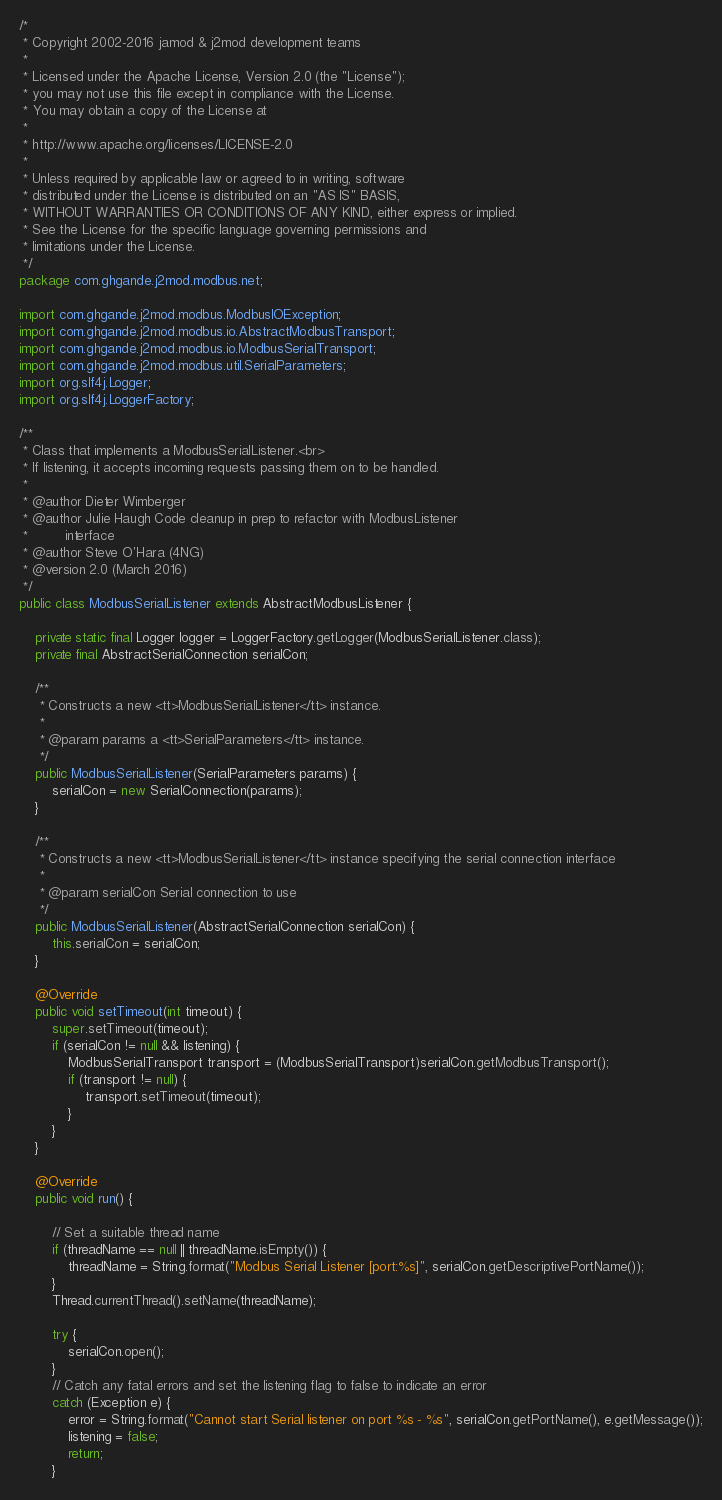<code> <loc_0><loc_0><loc_500><loc_500><_Java_>/*
 * Copyright 2002-2016 jamod & j2mod development teams
 *
 * Licensed under the Apache License, Version 2.0 (the "License");
 * you may not use this file except in compliance with the License.
 * You may obtain a copy of the License at
 *
 * http://www.apache.org/licenses/LICENSE-2.0
 *
 * Unless required by applicable law or agreed to in writing, software
 * distributed under the License is distributed on an "AS IS" BASIS,
 * WITHOUT WARRANTIES OR CONDITIONS OF ANY KIND, either express or implied.
 * See the License for the specific language governing permissions and
 * limitations under the License.
 */
package com.ghgande.j2mod.modbus.net;

import com.ghgande.j2mod.modbus.ModbusIOException;
import com.ghgande.j2mod.modbus.io.AbstractModbusTransport;
import com.ghgande.j2mod.modbus.io.ModbusSerialTransport;
import com.ghgande.j2mod.modbus.util.SerialParameters;
import org.slf4j.Logger;
import org.slf4j.LoggerFactory;

/**
 * Class that implements a ModbusSerialListener.<br>
 * If listening, it accepts incoming requests passing them on to be handled.
 *
 * @author Dieter Wimberger
 * @author Julie Haugh Code cleanup in prep to refactor with ModbusListener
 *         interface
 * @author Steve O'Hara (4NG)
 * @version 2.0 (March 2016)
 */
public class ModbusSerialListener extends AbstractModbusListener {

    private static final Logger logger = LoggerFactory.getLogger(ModbusSerialListener.class);
    private final AbstractSerialConnection serialCon;

    /**
     * Constructs a new <tt>ModbusSerialListener</tt> instance.
     *
     * @param params a <tt>SerialParameters</tt> instance.
     */
    public ModbusSerialListener(SerialParameters params) {
        serialCon = new SerialConnection(params);
    }

    /**
     * Constructs a new <tt>ModbusSerialListener</tt> instance specifying the serial connection interface
     *
     * @param serialCon Serial connection to use
     */
    public ModbusSerialListener(AbstractSerialConnection serialCon) {
        this.serialCon = serialCon;
    }

    @Override
    public void setTimeout(int timeout) {
        super.setTimeout(timeout);
        if (serialCon != null && listening) {
            ModbusSerialTransport transport = (ModbusSerialTransport)serialCon.getModbusTransport();
            if (transport != null) {
                transport.setTimeout(timeout);
            }
        }
    }

    @Override
    public void run() {

        // Set a suitable thread name
        if (threadName == null || threadName.isEmpty()) {
            threadName = String.format("Modbus Serial Listener [port:%s]", serialCon.getDescriptivePortName());
        }
        Thread.currentThread().setName(threadName);

        try {
            serialCon.open();
        }
        // Catch any fatal errors and set the listening flag to false to indicate an error
        catch (Exception e) {
            error = String.format("Cannot start Serial listener on port %s - %s", serialCon.getPortName(), e.getMessage());
            listening = false;
            return;
        }
</code> 